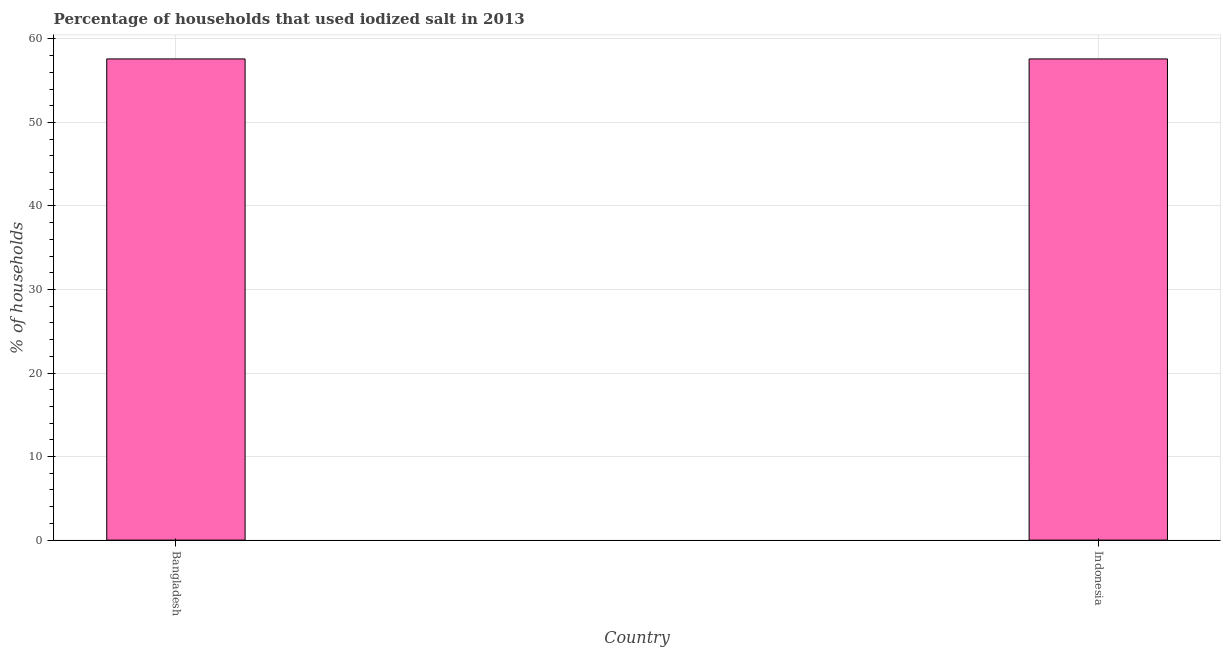Does the graph contain any zero values?
Your answer should be compact. No. Does the graph contain grids?
Ensure brevity in your answer.  Yes. What is the title of the graph?
Offer a terse response. Percentage of households that used iodized salt in 2013. What is the label or title of the X-axis?
Make the answer very short. Country. What is the label or title of the Y-axis?
Your answer should be very brief. % of households. What is the percentage of households where iodized salt is consumed in Indonesia?
Ensure brevity in your answer.  57.6. Across all countries, what is the maximum percentage of households where iodized salt is consumed?
Your answer should be compact. 57.6. Across all countries, what is the minimum percentage of households where iodized salt is consumed?
Your answer should be compact. 57.6. In which country was the percentage of households where iodized salt is consumed maximum?
Keep it short and to the point. Bangladesh. What is the sum of the percentage of households where iodized salt is consumed?
Your response must be concise. 115.2. What is the difference between the percentage of households where iodized salt is consumed in Bangladesh and Indonesia?
Your answer should be compact. 0. What is the average percentage of households where iodized salt is consumed per country?
Keep it short and to the point. 57.6. What is the median percentage of households where iodized salt is consumed?
Provide a short and direct response. 57.6. What is the ratio of the percentage of households where iodized salt is consumed in Bangladesh to that in Indonesia?
Offer a very short reply. 1. Is the percentage of households where iodized salt is consumed in Bangladesh less than that in Indonesia?
Ensure brevity in your answer.  No. Are all the bars in the graph horizontal?
Provide a short and direct response. No. What is the difference between two consecutive major ticks on the Y-axis?
Provide a short and direct response. 10. What is the % of households of Bangladesh?
Keep it short and to the point. 57.6. What is the % of households of Indonesia?
Give a very brief answer. 57.6. What is the difference between the % of households in Bangladesh and Indonesia?
Keep it short and to the point. 0. What is the ratio of the % of households in Bangladesh to that in Indonesia?
Your response must be concise. 1. 